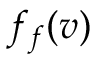<formula> <loc_0><loc_0><loc_500><loc_500>f _ { f } ( v )</formula> 